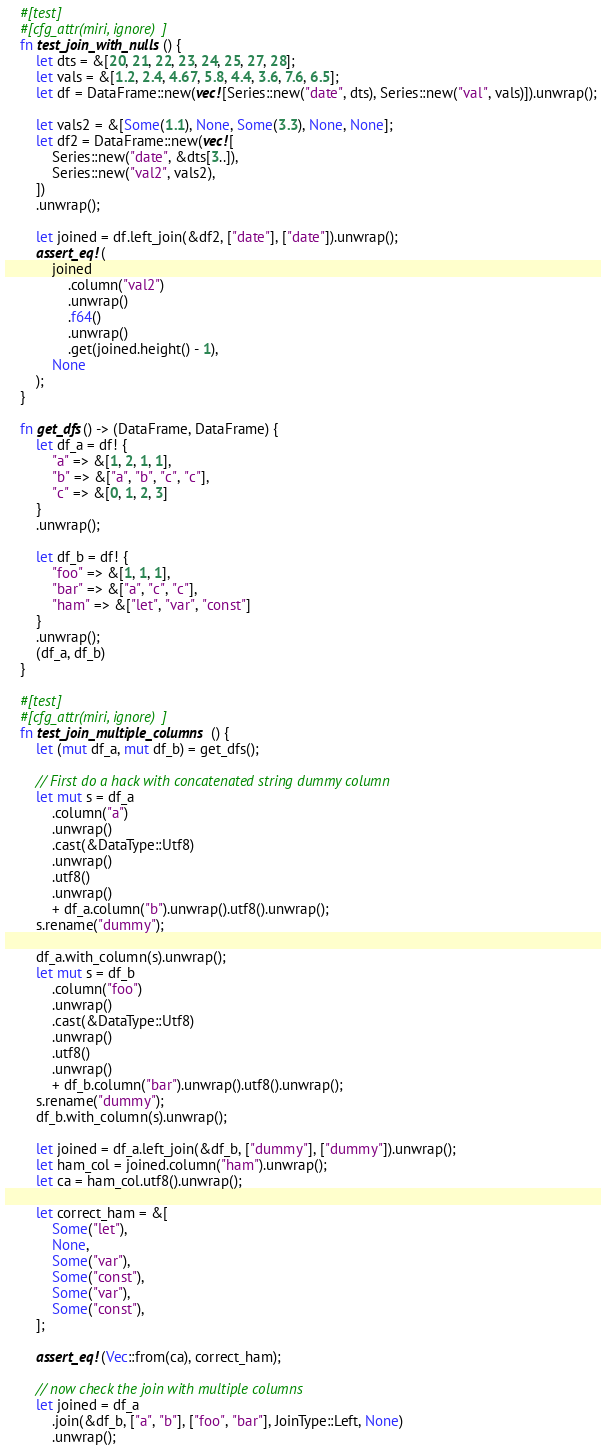Convert code to text. <code><loc_0><loc_0><loc_500><loc_500><_Rust_>    #[test]
    #[cfg_attr(miri, ignore)]
    fn test_join_with_nulls() {
        let dts = &[20, 21, 22, 23, 24, 25, 27, 28];
        let vals = &[1.2, 2.4, 4.67, 5.8, 4.4, 3.6, 7.6, 6.5];
        let df = DataFrame::new(vec![Series::new("date", dts), Series::new("val", vals)]).unwrap();

        let vals2 = &[Some(1.1), None, Some(3.3), None, None];
        let df2 = DataFrame::new(vec![
            Series::new("date", &dts[3..]),
            Series::new("val2", vals2),
        ])
        .unwrap();

        let joined = df.left_join(&df2, ["date"], ["date"]).unwrap();
        assert_eq!(
            joined
                .column("val2")
                .unwrap()
                .f64()
                .unwrap()
                .get(joined.height() - 1),
            None
        );
    }

    fn get_dfs() -> (DataFrame, DataFrame) {
        let df_a = df! {
            "a" => &[1, 2, 1, 1],
            "b" => &["a", "b", "c", "c"],
            "c" => &[0, 1, 2, 3]
        }
        .unwrap();

        let df_b = df! {
            "foo" => &[1, 1, 1],
            "bar" => &["a", "c", "c"],
            "ham" => &["let", "var", "const"]
        }
        .unwrap();
        (df_a, df_b)
    }

    #[test]
    #[cfg_attr(miri, ignore)]
    fn test_join_multiple_columns() {
        let (mut df_a, mut df_b) = get_dfs();

        // First do a hack with concatenated string dummy column
        let mut s = df_a
            .column("a")
            .unwrap()
            .cast(&DataType::Utf8)
            .unwrap()
            .utf8()
            .unwrap()
            + df_a.column("b").unwrap().utf8().unwrap();
        s.rename("dummy");

        df_a.with_column(s).unwrap();
        let mut s = df_b
            .column("foo")
            .unwrap()
            .cast(&DataType::Utf8)
            .unwrap()
            .utf8()
            .unwrap()
            + df_b.column("bar").unwrap().utf8().unwrap();
        s.rename("dummy");
        df_b.with_column(s).unwrap();

        let joined = df_a.left_join(&df_b, ["dummy"], ["dummy"]).unwrap();
        let ham_col = joined.column("ham").unwrap();
        let ca = ham_col.utf8().unwrap();

        let correct_ham = &[
            Some("let"),
            None,
            Some("var"),
            Some("const"),
            Some("var"),
            Some("const"),
        ];

        assert_eq!(Vec::from(ca), correct_ham);

        // now check the join with multiple columns
        let joined = df_a
            .join(&df_b, ["a", "b"], ["foo", "bar"], JoinType::Left, None)
            .unwrap();</code> 